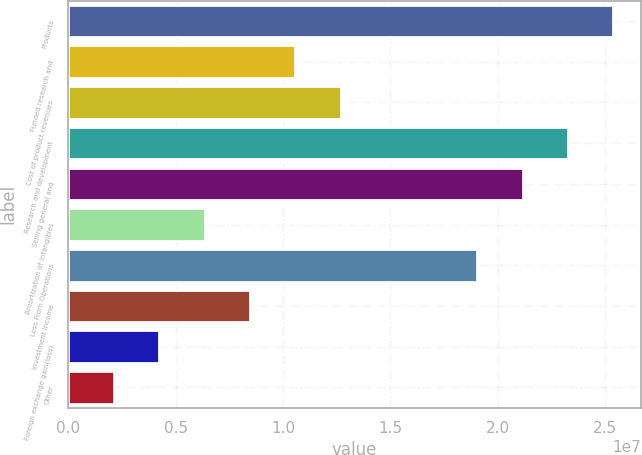Convert chart to OTSL. <chart><loc_0><loc_0><loc_500><loc_500><bar_chart><fcel>Products<fcel>Funded research and<fcel>Cost of product revenues<fcel>Research and development<fcel>Selling general and<fcel>Amortization of intangibles<fcel>Loss From Operations<fcel>Investment income<fcel>Foreign exchange gain(loss)<fcel>Other<nl><fcel>2.53836e+07<fcel>1.05765e+07<fcel>1.26918e+07<fcel>2.32683e+07<fcel>2.1153e+07<fcel>6.3459e+06<fcel>1.90377e+07<fcel>8.46121e+06<fcel>4.2306e+06<fcel>2.1153e+06<nl></chart> 